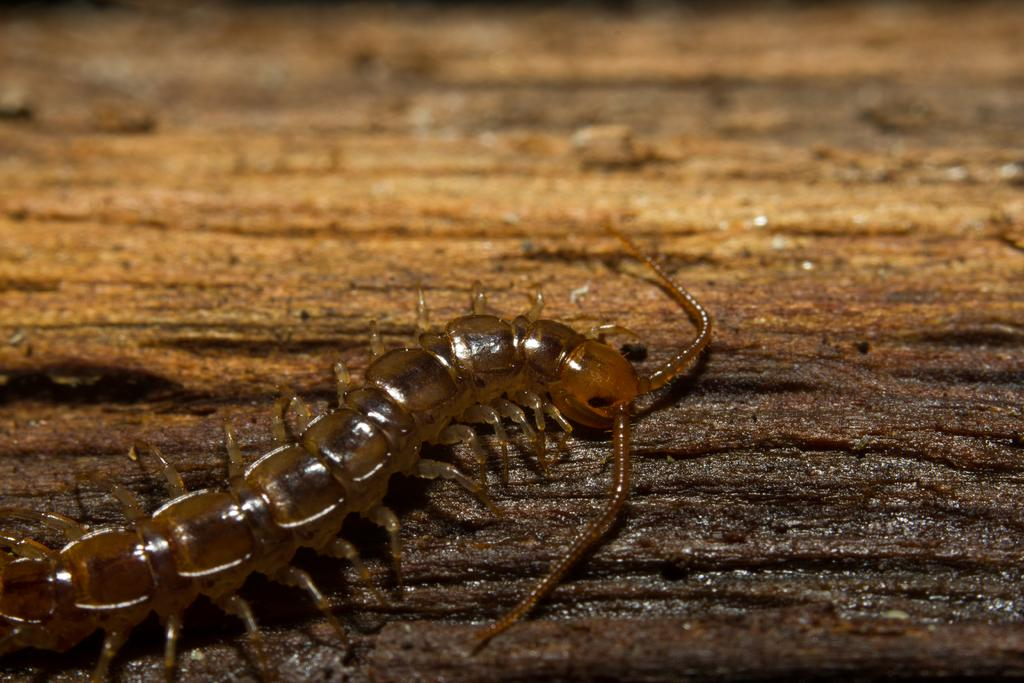What type of creature is present in the image? There is an insect in the image. What color is the insect? The insect is brown in color. What is the insect sitting on in the image? The insect is on a brown color surface. What is the insect's opinion on the current political climate? Insects do not have opinions, as they are not capable of forming or expressing opinions. What type of paint is used to color the insect in the image? The insect is not painted; it is naturally brown in color. 